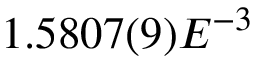<formula> <loc_0><loc_0><loc_500><loc_500>1 . 5 8 0 7 ( 9 ) E ^ { - 3 }</formula> 